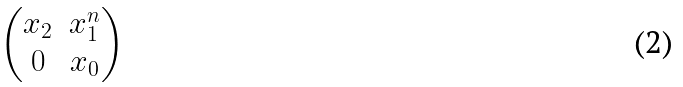<formula> <loc_0><loc_0><loc_500><loc_500>\begin{pmatrix} x _ { 2 } & x _ { 1 } ^ { n } \\ 0 & x _ { 0 } \end{pmatrix}</formula> 